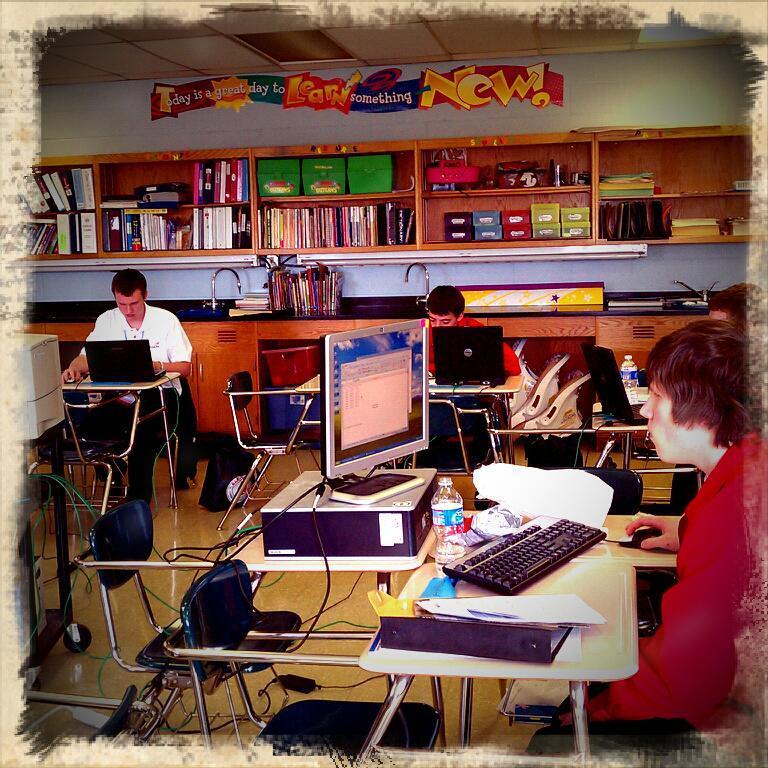How would you summarize this image in a sentence or two? This Picture describe about the inside view of the room , In which a woman is sitting on the chair and working on the computer which is placed on the table, We can see a water bottle , keyboard file and mouse on it. Behind we can see a boy wearing red t-shirt and working on the laptop. On the top we can see a wooden rack full of books and on left side a person wearing white shirt is working on the laptop. 